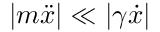<formula> <loc_0><loc_0><loc_500><loc_500>| m \ddot { x } | \ll | \gamma \dot { x } |</formula> 